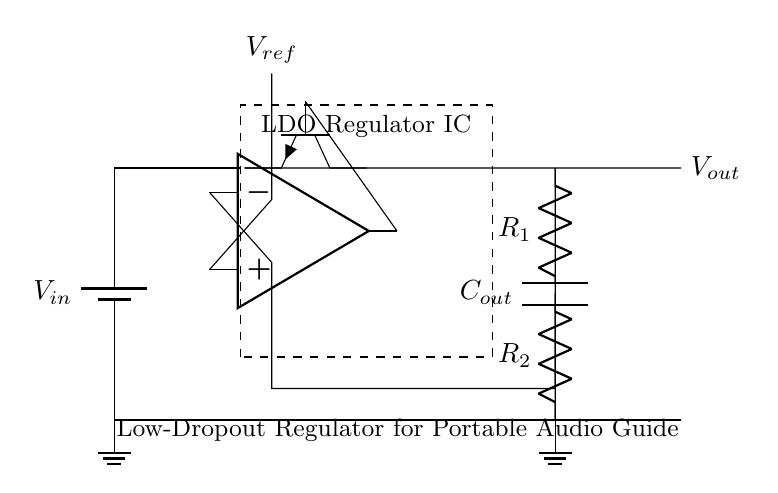What component provides the input voltage? The input voltage in the circuit is provided by a battery, as indicated by the "V_in" label connected at the top left of the diagram.
Answer: Battery What is the function of the error amplifier? The error amplifier compares the output voltage to a reference voltage, adjusting the pass transistor's operation to maintain a consistent output voltage, ensuring that the circuit delivers stable power to the audio guide device.
Answer: Voltage regulation What type of transistors are used in this circuit? The circuit uses a single NPN transistor as a pass element, specifically referenced by the symbol 'Q1' which is shown in a rotated position, indicating it is used to regulate the output voltage.
Answer: NPN What is the value of the output capacitor labeled as? The output capacitor is labeled "C_out," and it is responsible for smoothing the output voltage and reducing voltage ripple by providing a reservoir of charge.
Answer: C_out How many resistors are in the feedback network? The circuit contains two resistors in the feedback network, labeled "R1" and "R2," which are used to set the output voltage based on the values of these resistors.
Answer: Two What is the purpose of the dashed rectangle around the LDO regulator? The dashed rectangle signifies the encapsulation of the Low Dropout Regulator IC, indicating that it is a distinct component that contains internal circuitry for effective voltage regulation and should not be modified.
Answer: To indicate the LDO IC What is the reference voltage denoted as? The reference voltage is denoted as "V_ref," and it is critical for the error amplifier to maintain the desired output voltage level by functioning as a benchmark for comparison.
Answer: V_ref 